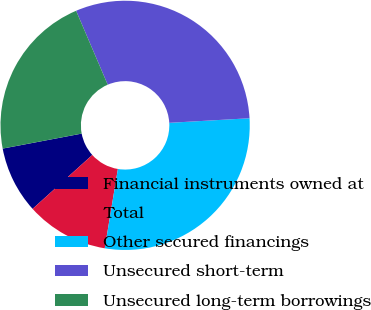Convert chart. <chart><loc_0><loc_0><loc_500><loc_500><pie_chart><fcel>Financial instruments owned at<fcel>Total<fcel>Other secured financings<fcel>Unsecured short-term<fcel>Unsecured long-term borrowings<nl><fcel>8.7%<fcel>10.7%<fcel>28.52%<fcel>30.52%<fcel>21.55%<nl></chart> 